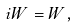<formula> <loc_0><loc_0><loc_500><loc_500>i W = W ,</formula> 